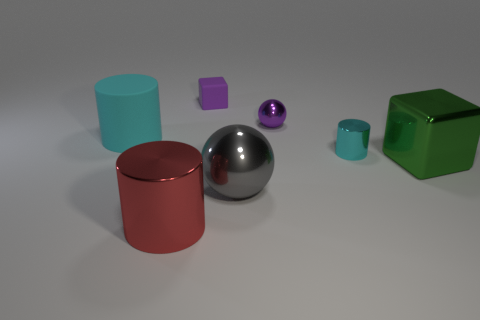How many spheres are behind the large rubber thing?
Provide a succinct answer. 1. What color is the matte cylinder?
Your answer should be compact. Cyan. How many large objects are purple rubber things or brown shiny balls?
Your answer should be compact. 0. Does the ball that is behind the large cube have the same color as the cube that is behind the rubber cylinder?
Provide a succinct answer. Yes. What number of other things are the same color as the large cube?
Ensure brevity in your answer.  0. There is a big object to the right of the large gray shiny sphere; what shape is it?
Make the answer very short. Cube. Is the number of big brown matte blocks less than the number of cyan metallic cylinders?
Ensure brevity in your answer.  Yes. Are the big object that is behind the large green metallic thing and the small block made of the same material?
Offer a terse response. Yes. There is a small matte object; are there any green shiny cubes right of it?
Provide a succinct answer. Yes. What color is the large thing that is behind the metal thing that is to the right of the cyan cylinder right of the purple cube?
Make the answer very short. Cyan. 